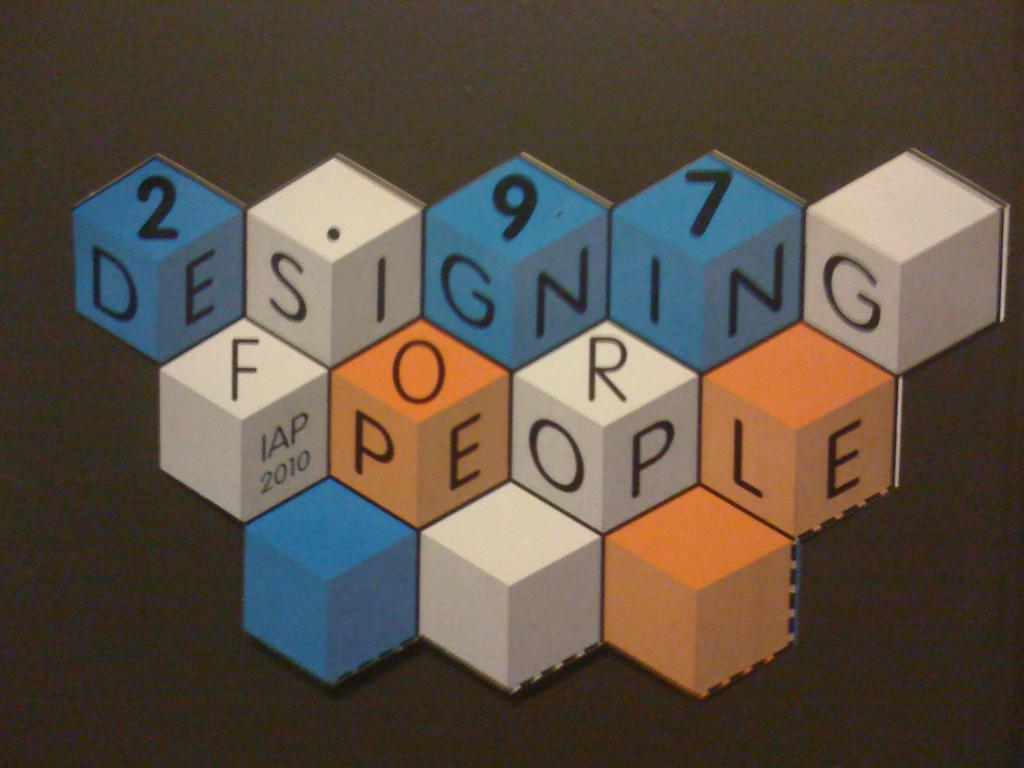<image>
Summarize the visual content of the image. A series of blue, white, and orange blocks spell out designing for people, made by the company IAP in 2010. 